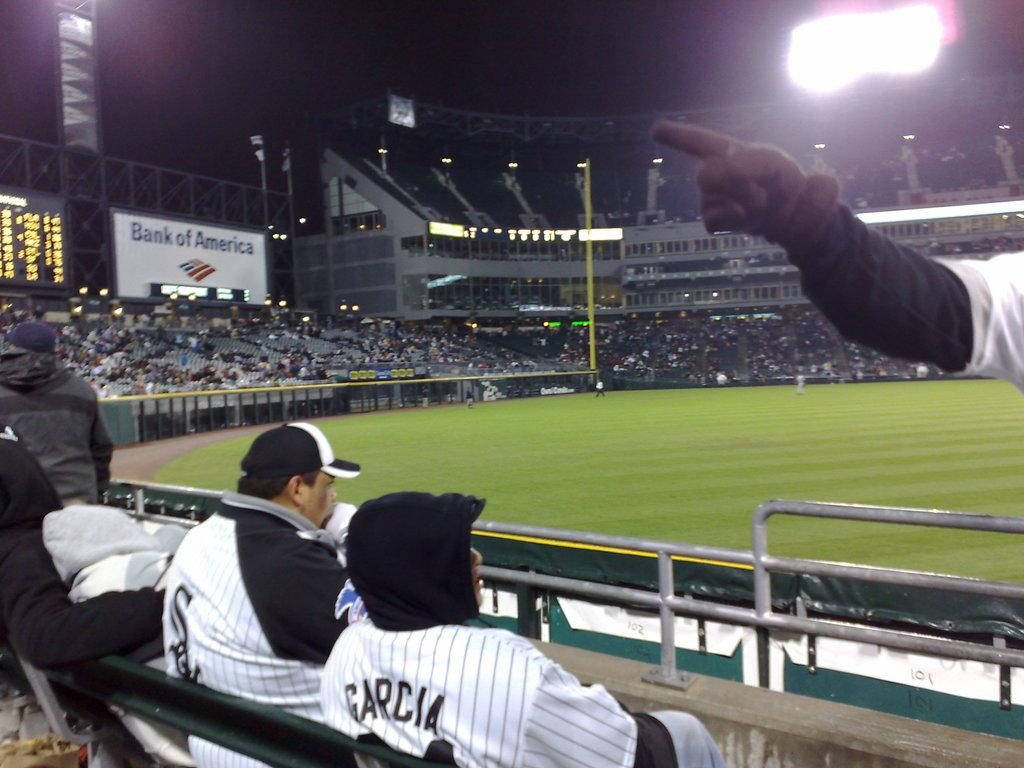<image>
Present a compact description of the photo's key features. Two men in baseball shirts are looking out into the field with one of them having the name garcia on his back. 